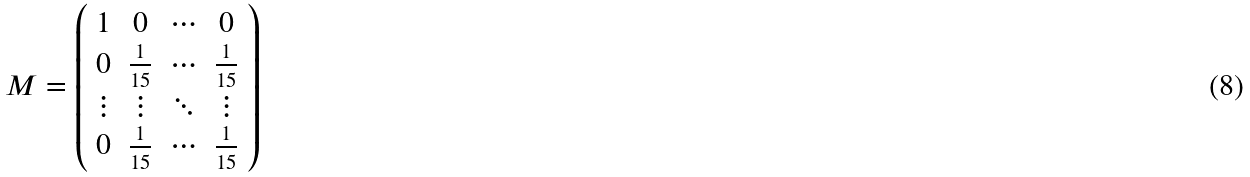<formula> <loc_0><loc_0><loc_500><loc_500>M = \left ( \begin{array} { c c c c } 1 & 0 & \cdots & 0 \\ 0 & \frac { 1 } { 1 5 } & \cdots & \frac { 1 } { 1 5 } \\ \vdots & \vdots & \ddots & \vdots \\ 0 & \frac { 1 } { 1 5 } & \cdots & \frac { 1 } { 1 5 } \end{array} \right )</formula> 